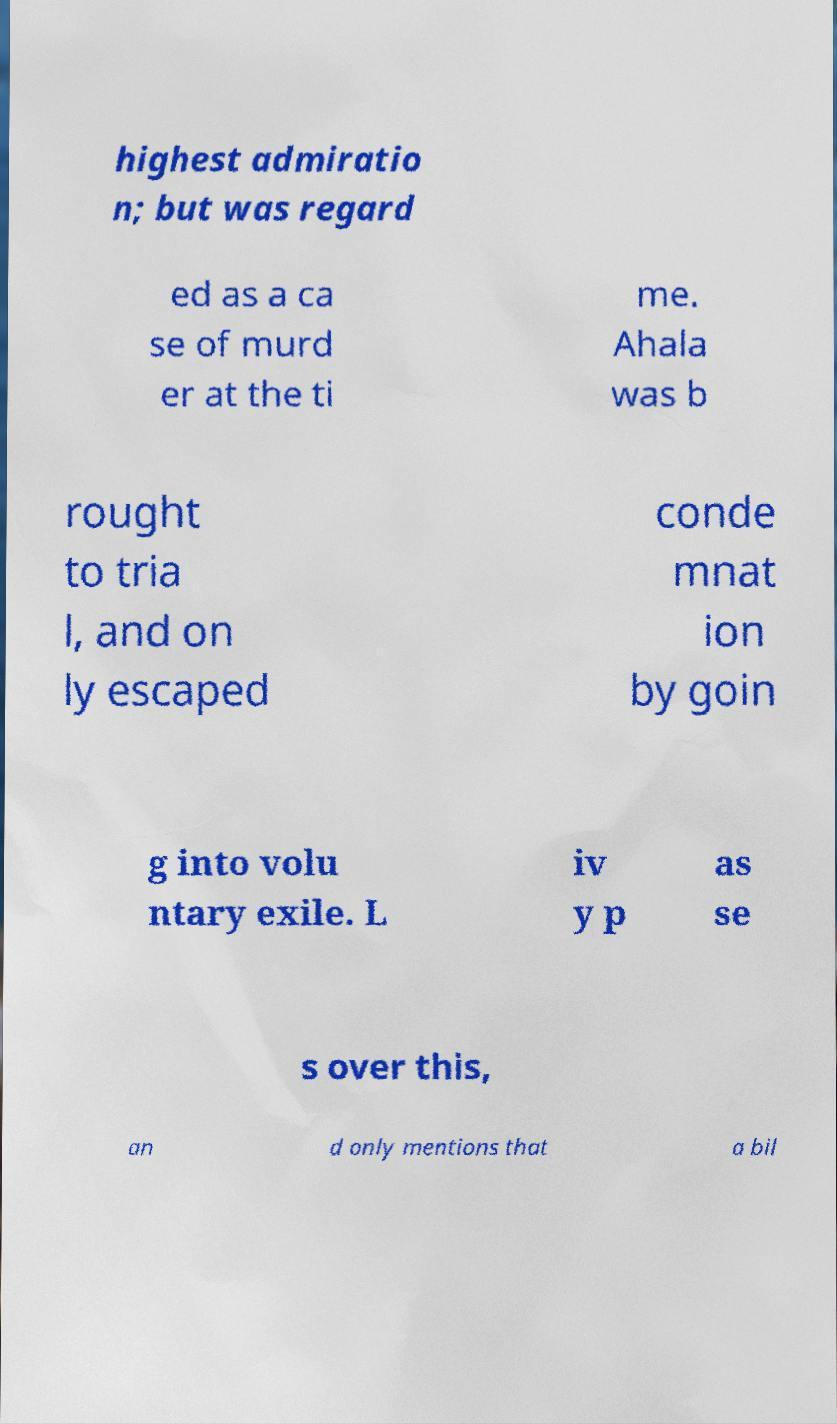For documentation purposes, I need the text within this image transcribed. Could you provide that? highest admiratio n; but was regard ed as a ca se of murd er at the ti me. Ahala was b rought to tria l, and on ly escaped conde mnat ion by goin g into volu ntary exile. L iv y p as se s over this, an d only mentions that a bil 